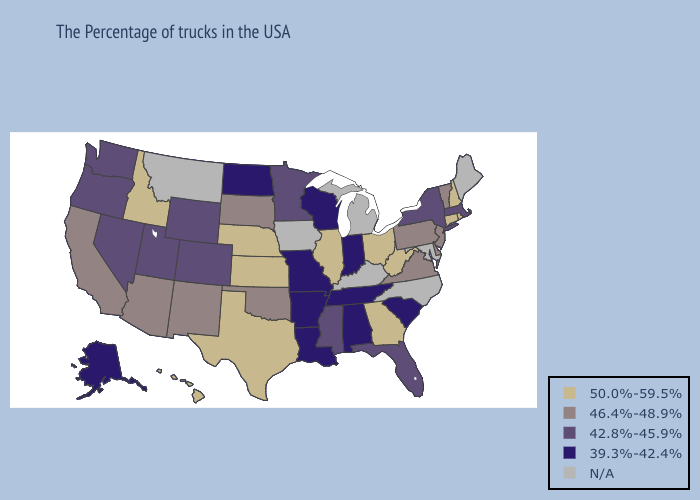What is the highest value in the Northeast ?
Give a very brief answer. 50.0%-59.5%. Among the states that border Colorado , does Wyoming have the highest value?
Be succinct. No. Does Vermont have the highest value in the USA?
Give a very brief answer. No. Name the states that have a value in the range 46.4%-48.9%?
Give a very brief answer. Vermont, New Jersey, Delaware, Pennsylvania, Virginia, Oklahoma, South Dakota, New Mexico, Arizona, California. Among the states that border Mississippi , which have the lowest value?
Short answer required. Alabama, Tennessee, Louisiana, Arkansas. What is the highest value in states that border Rhode Island?
Give a very brief answer. 50.0%-59.5%. Which states hav the highest value in the MidWest?
Quick response, please. Ohio, Illinois, Kansas, Nebraska. Which states have the lowest value in the South?
Be succinct. South Carolina, Alabama, Tennessee, Louisiana, Arkansas. Which states have the lowest value in the MidWest?
Give a very brief answer. Indiana, Wisconsin, Missouri, North Dakota. Does North Dakota have the highest value in the USA?
Write a very short answer. No. Which states have the highest value in the USA?
Write a very short answer. Rhode Island, New Hampshire, Connecticut, West Virginia, Ohio, Georgia, Illinois, Kansas, Nebraska, Texas, Idaho, Hawaii. What is the value of Vermont?
Answer briefly. 46.4%-48.9%. Name the states that have a value in the range 42.8%-45.9%?
Write a very short answer. Massachusetts, New York, Florida, Mississippi, Minnesota, Wyoming, Colorado, Utah, Nevada, Washington, Oregon. 